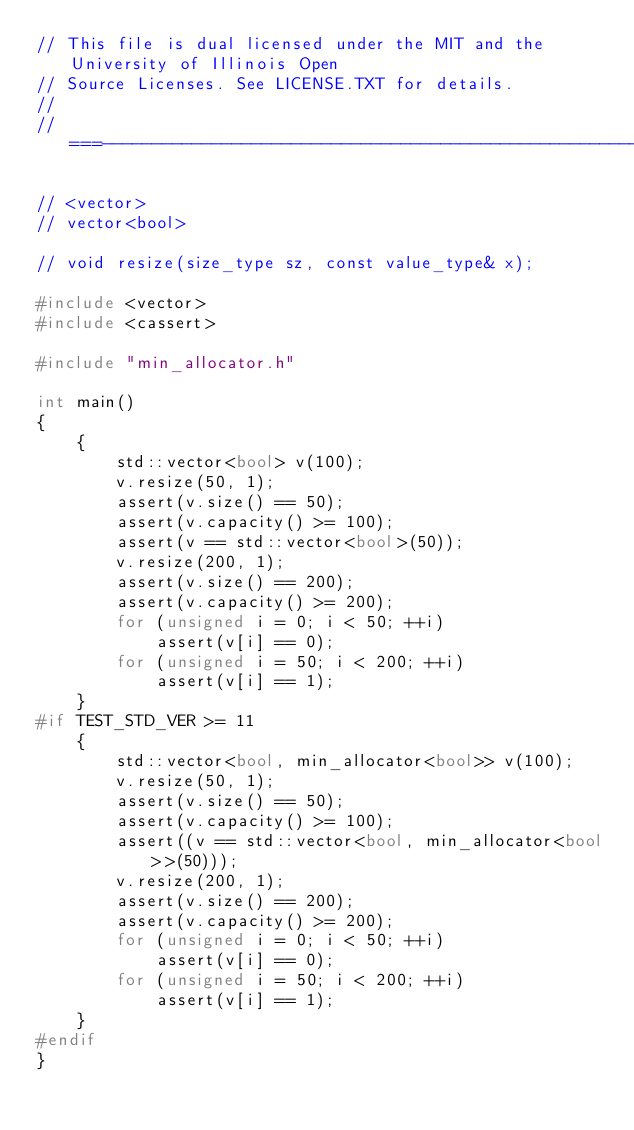<code> <loc_0><loc_0><loc_500><loc_500><_C++_>// This file is dual licensed under the MIT and the University of Illinois Open
// Source Licenses. See LICENSE.TXT for details.
//
//===----------------------------------------------------------------------===//

// <vector>
// vector<bool>

// void resize(size_type sz, const value_type& x);

#include <vector>
#include <cassert>

#include "min_allocator.h"

int main()
{
    {
        std::vector<bool> v(100);
        v.resize(50, 1);
        assert(v.size() == 50);
        assert(v.capacity() >= 100);
        assert(v == std::vector<bool>(50));
        v.resize(200, 1);
        assert(v.size() == 200);
        assert(v.capacity() >= 200);
        for (unsigned i = 0; i < 50; ++i)
            assert(v[i] == 0);
        for (unsigned i = 50; i < 200; ++i)
            assert(v[i] == 1);
    }
#if TEST_STD_VER >= 11
    {
        std::vector<bool, min_allocator<bool>> v(100);
        v.resize(50, 1);
        assert(v.size() == 50);
        assert(v.capacity() >= 100);
        assert((v == std::vector<bool, min_allocator<bool>>(50)));
        v.resize(200, 1);
        assert(v.size() == 200);
        assert(v.capacity() >= 200);
        for (unsigned i = 0; i < 50; ++i)
            assert(v[i] == 0);
        for (unsigned i = 50; i < 200; ++i)
            assert(v[i] == 1);
    }
#endif
}
</code> 